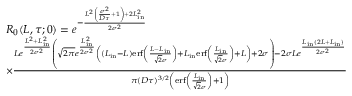Convert formula to latex. <formula><loc_0><loc_0><loc_500><loc_500>\begin{array} { r l } & { R _ { 0 } ( L , \tau ; 0 ) = e ^ { - \frac { L ^ { 2 } \left ( \frac { \sigma ^ { 2 } } { D \tau } + 1 \right ) + 2 L _ { i n } ^ { 2 } } { 2 \sigma ^ { 2 } } } } \\ & { \times \frac { L e ^ { \frac { L ^ { 2 } + L _ { i n } ^ { 2 } } { 2 \sigma ^ { 2 } } } \left ( \sqrt { 2 \pi } e ^ { \frac { L _ { i n } ^ { 2 } } { 2 \sigma ^ { 2 } } } \left ( ( L _ { i n } - L ) e r f \left ( \frac { L - L _ { i n } } { \sqrt { 2 } \sigma } \right ) + L _ { i n } e r f \left ( \frac { L _ { i n } } { \sqrt { 2 } \sigma } \right ) + L \right ) + 2 \sigma \right ) - 2 \sigma L e ^ { \frac { L _ { i n } ( 2 L + L _ { i n } ) } { 2 \sigma ^ { 2 } } } } { \pi ( D \tau ) ^ { 3 / 2 } \left ( e r f \left ( \frac { L _ { i n } } { \sqrt { 2 } \sigma } \right ) + 1 \right ) } } \end{array}</formula> 